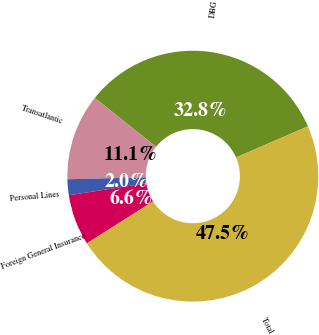Convert chart to OTSL. <chart><loc_0><loc_0><loc_500><loc_500><pie_chart><fcel>DBG<fcel>Transatlantic<fcel>Personal Lines<fcel>Foreign General Insurance<fcel>Total<nl><fcel>32.77%<fcel>11.12%<fcel>2.03%<fcel>6.57%<fcel>47.5%<nl></chart> 